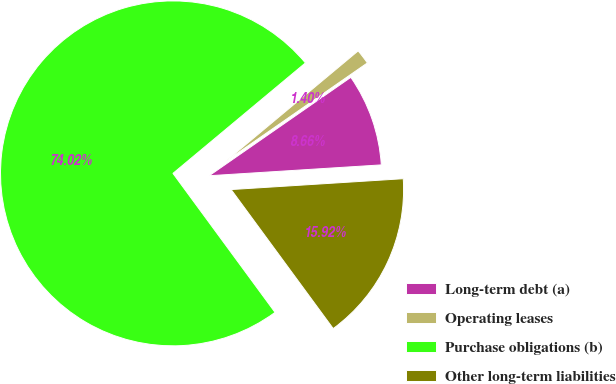Convert chart to OTSL. <chart><loc_0><loc_0><loc_500><loc_500><pie_chart><fcel>Long-term debt (a)<fcel>Operating leases<fcel>Purchase obligations (b)<fcel>Other long-term liabilities<nl><fcel>8.66%<fcel>1.4%<fcel>74.01%<fcel>15.92%<nl></chart> 